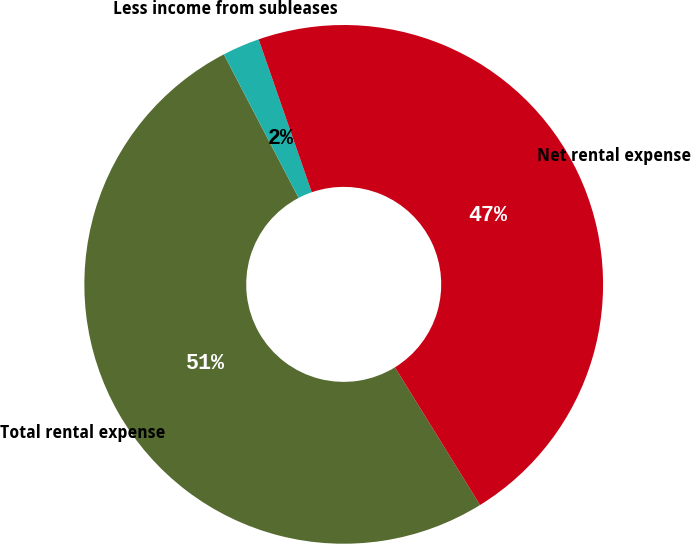Convert chart to OTSL. <chart><loc_0><loc_0><loc_500><loc_500><pie_chart><fcel>Total rental expense<fcel>Less income from subleases<fcel>Net rental expense<nl><fcel>51.16%<fcel>2.33%<fcel>46.51%<nl></chart> 